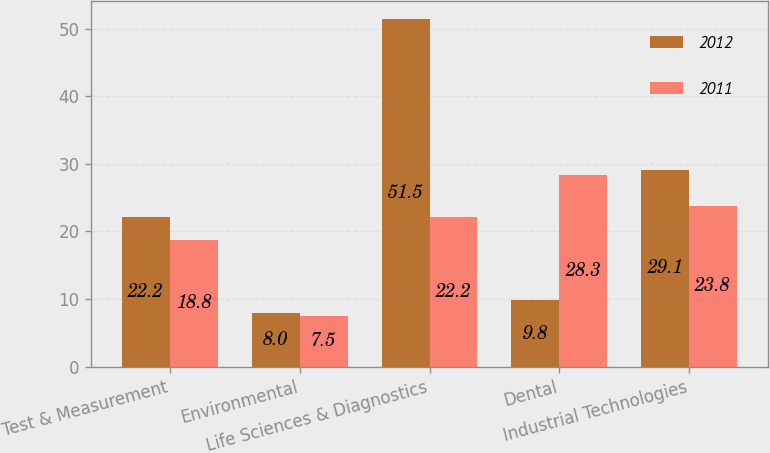<chart> <loc_0><loc_0><loc_500><loc_500><stacked_bar_chart><ecel><fcel>Test & Measurement<fcel>Environmental<fcel>Life Sciences & Diagnostics<fcel>Dental<fcel>Industrial Technologies<nl><fcel>2012<fcel>22.2<fcel>8<fcel>51.5<fcel>9.8<fcel>29.1<nl><fcel>2011<fcel>18.8<fcel>7.5<fcel>22.2<fcel>28.3<fcel>23.8<nl></chart> 